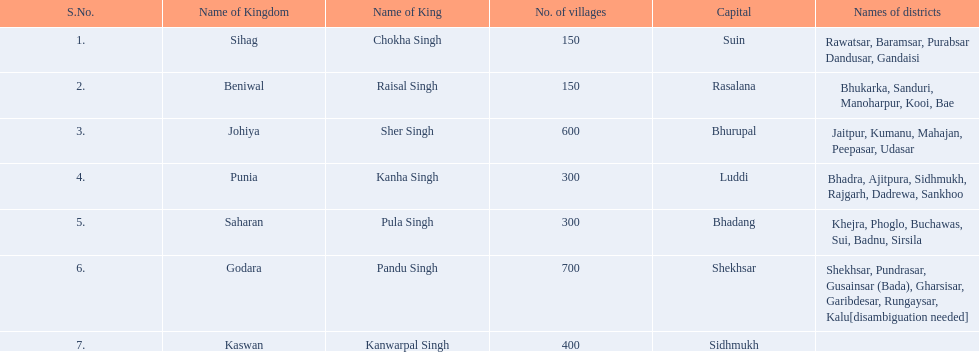In which dominion were there the smallest number of villages together with sihag? Beniwal. In which dominion were there the largest number of villages? Godara. Which village had an equal number of villages as godara, ranking second highest? Johiya. 